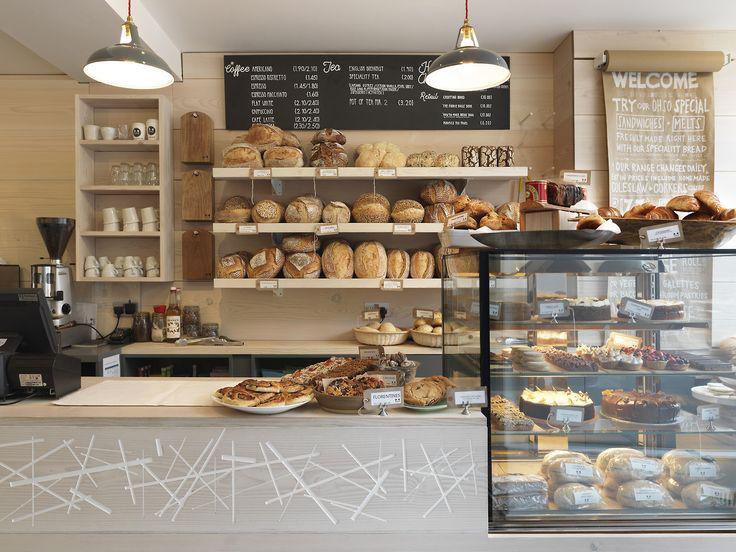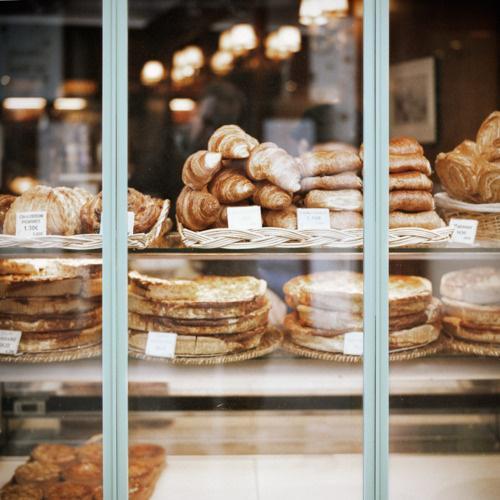The first image is the image on the left, the second image is the image on the right. Examine the images to the left and right. Is the description "Product information is written in white on black signs in at least one image." accurate? Answer yes or no. Yes. 